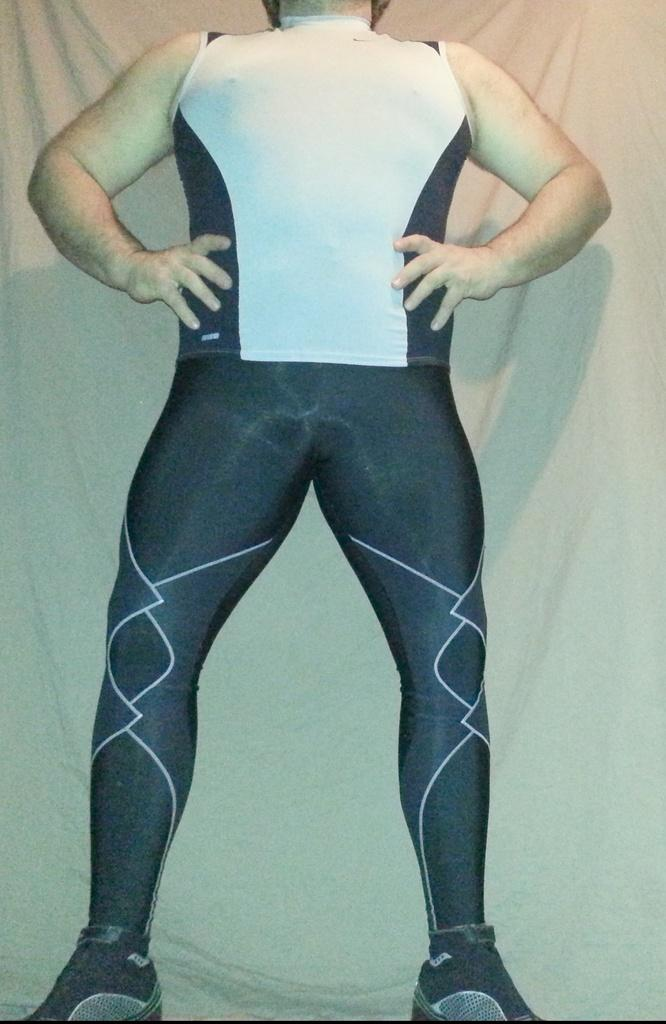What is the person in the image wearing? The person in the image is wearing a black and white dress. What type of footwear is the person wearing? The person is wearing shoes. What color is the background of the image? The background of the image is white. What type of maid is visible in the image? There is no maid present in the image. Is the person in the image standing on a dock? There is no dock present in the image. 